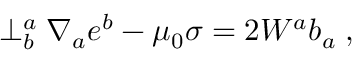<formula> <loc_0><loc_0><loc_500><loc_500>\perp _ { b } ^ { a } \nabla _ { a } e ^ { b } - \mu _ { 0 } \sigma = 2 W ^ { a } b _ { a } \, ,</formula> 